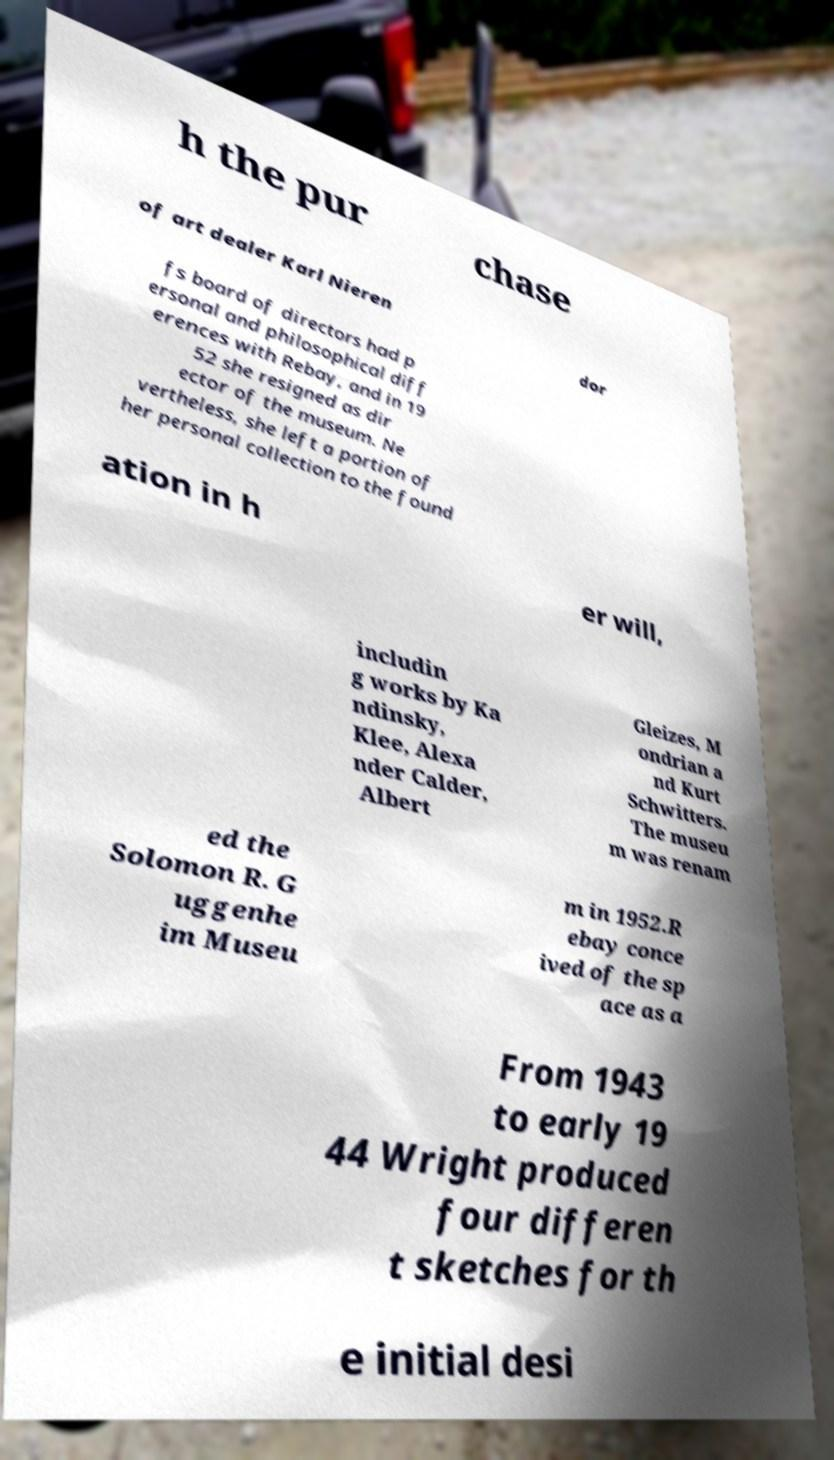Could you extract and type out the text from this image? h the pur chase of art dealer Karl Nieren dor fs board of directors had p ersonal and philosophical diff erences with Rebay, and in 19 52 she resigned as dir ector of the museum. Ne vertheless, she left a portion of her personal collection to the found ation in h er will, includin g works by Ka ndinsky, Klee, Alexa nder Calder, Albert Gleizes, M ondrian a nd Kurt Schwitters. The museu m was renam ed the Solomon R. G uggenhe im Museu m in 1952.R ebay conce ived of the sp ace as a From 1943 to early 19 44 Wright produced four differen t sketches for th e initial desi 